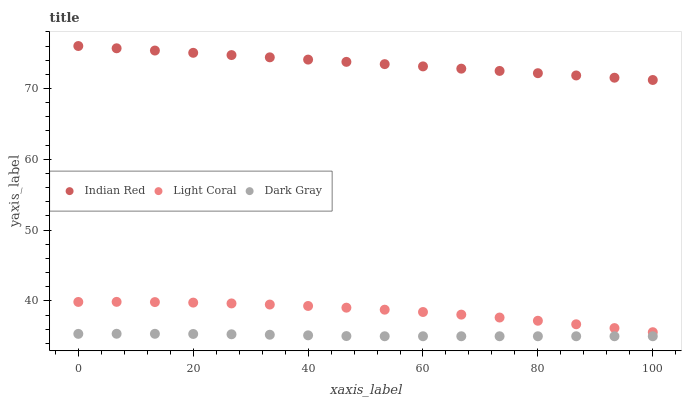Does Dark Gray have the minimum area under the curve?
Answer yes or no. Yes. Does Indian Red have the maximum area under the curve?
Answer yes or no. Yes. Does Indian Red have the minimum area under the curve?
Answer yes or no. No. Does Dark Gray have the maximum area under the curve?
Answer yes or no. No. Is Indian Red the smoothest?
Answer yes or no. Yes. Is Light Coral the roughest?
Answer yes or no. Yes. Is Dark Gray the smoothest?
Answer yes or no. No. Is Dark Gray the roughest?
Answer yes or no. No. Does Dark Gray have the lowest value?
Answer yes or no. Yes. Does Indian Red have the lowest value?
Answer yes or no. No. Does Indian Red have the highest value?
Answer yes or no. Yes. Does Dark Gray have the highest value?
Answer yes or no. No. Is Light Coral less than Indian Red?
Answer yes or no. Yes. Is Light Coral greater than Dark Gray?
Answer yes or no. Yes. Does Light Coral intersect Indian Red?
Answer yes or no. No. 